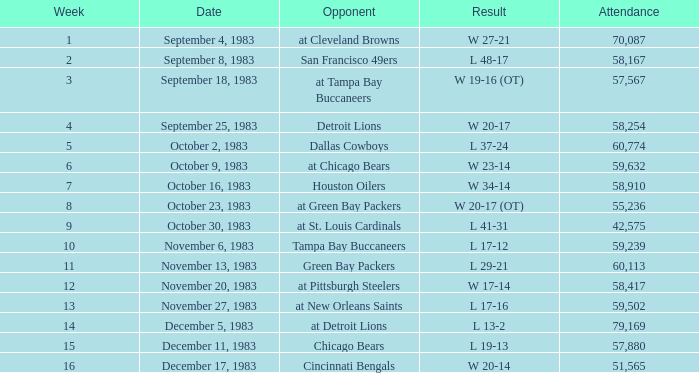Can you describe the events that transpired before week 15 on november 20, 1983? W 17-14. 